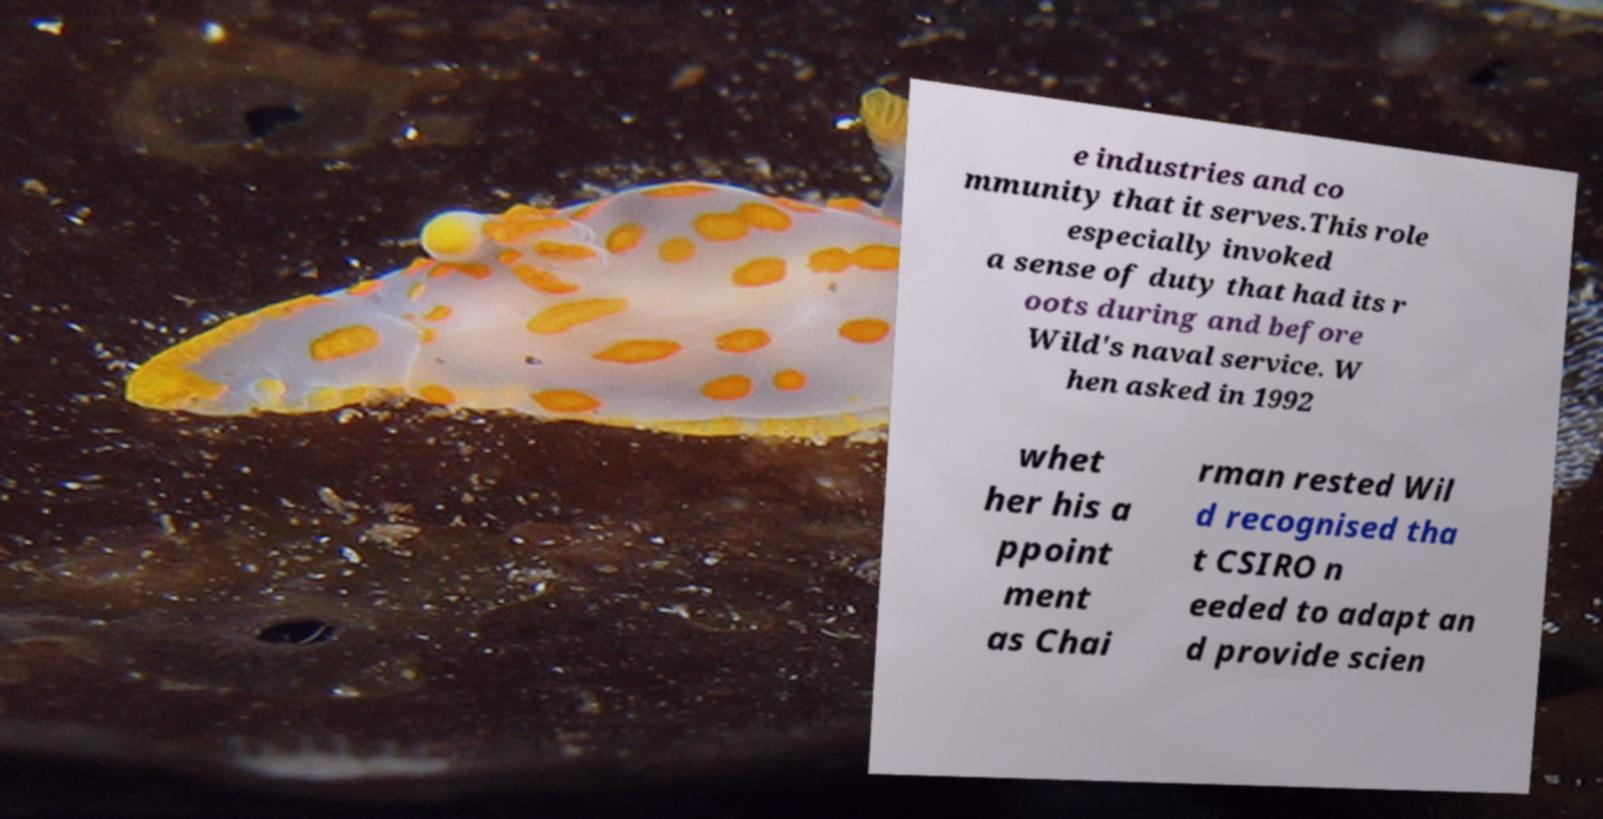For documentation purposes, I need the text within this image transcribed. Could you provide that? e industries and co mmunity that it serves.This role especially invoked a sense of duty that had its r oots during and before Wild's naval service. W hen asked in 1992 whet her his a ppoint ment as Chai rman rested Wil d recognised tha t CSIRO n eeded to adapt an d provide scien 